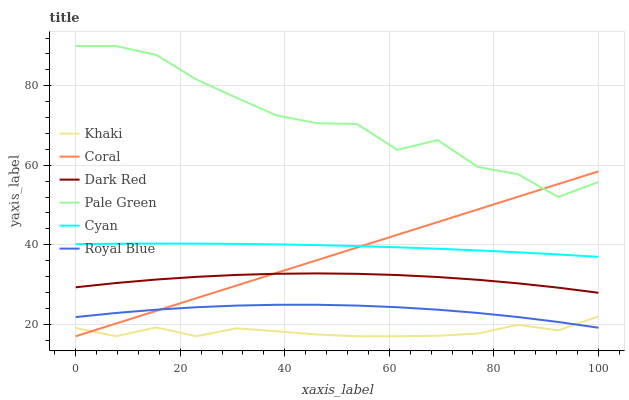Does Khaki have the minimum area under the curve?
Answer yes or no. Yes. Does Pale Green have the maximum area under the curve?
Answer yes or no. Yes. Does Dark Red have the minimum area under the curve?
Answer yes or no. No. Does Dark Red have the maximum area under the curve?
Answer yes or no. No. Is Coral the smoothest?
Answer yes or no. Yes. Is Pale Green the roughest?
Answer yes or no. Yes. Is Dark Red the smoothest?
Answer yes or no. No. Is Dark Red the roughest?
Answer yes or no. No. Does Khaki have the lowest value?
Answer yes or no. Yes. Does Dark Red have the lowest value?
Answer yes or no. No. Does Pale Green have the highest value?
Answer yes or no. Yes. Does Dark Red have the highest value?
Answer yes or no. No. Is Cyan less than Pale Green?
Answer yes or no. Yes. Is Pale Green greater than Khaki?
Answer yes or no. Yes. Does Cyan intersect Coral?
Answer yes or no. Yes. Is Cyan less than Coral?
Answer yes or no. No. Is Cyan greater than Coral?
Answer yes or no. No. Does Cyan intersect Pale Green?
Answer yes or no. No. 